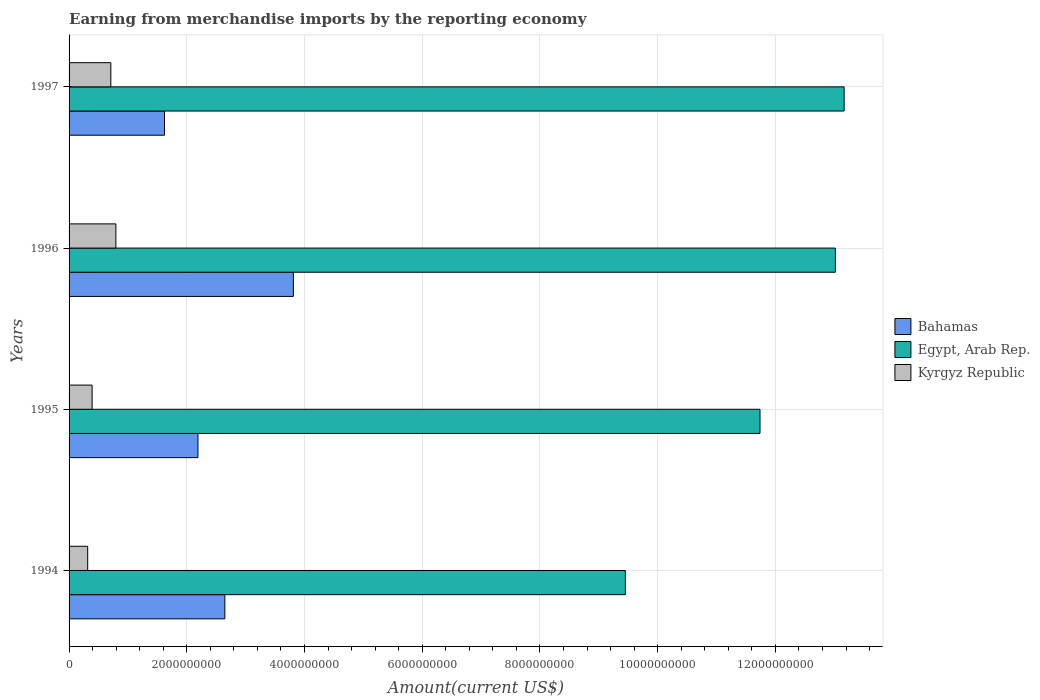Are the number of bars on each tick of the Y-axis equal?
Your answer should be very brief. Yes. How many bars are there on the 4th tick from the bottom?
Your response must be concise. 3. In how many cases, is the number of bars for a given year not equal to the number of legend labels?
Offer a terse response. 0. What is the amount earned from merchandise imports in Egypt, Arab Rep. in 1996?
Keep it short and to the point. 1.30e+1. Across all years, what is the maximum amount earned from merchandise imports in Kyrgyz Republic?
Ensure brevity in your answer.  7.95e+08. Across all years, what is the minimum amount earned from merchandise imports in Kyrgyz Republic?
Ensure brevity in your answer.  3.16e+08. What is the total amount earned from merchandise imports in Bahamas in the graph?
Provide a short and direct response. 1.03e+1. What is the difference between the amount earned from merchandise imports in Egypt, Arab Rep. in 1996 and that in 1997?
Your answer should be compact. -1.49e+08. What is the difference between the amount earned from merchandise imports in Kyrgyz Republic in 1994 and the amount earned from merchandise imports in Bahamas in 1996?
Keep it short and to the point. -3.49e+09. What is the average amount earned from merchandise imports in Bahamas per year?
Your answer should be very brief. 2.57e+09. In the year 1996, what is the difference between the amount earned from merchandise imports in Egypt, Arab Rep. and amount earned from merchandise imports in Kyrgyz Republic?
Ensure brevity in your answer.  1.22e+1. In how many years, is the amount earned from merchandise imports in Egypt, Arab Rep. greater than 400000000 US$?
Offer a terse response. 4. What is the ratio of the amount earned from merchandise imports in Kyrgyz Republic in 1994 to that in 1995?
Provide a short and direct response. 0.81. Is the difference between the amount earned from merchandise imports in Egypt, Arab Rep. in 1996 and 1997 greater than the difference between the amount earned from merchandise imports in Kyrgyz Republic in 1996 and 1997?
Give a very brief answer. No. What is the difference between the highest and the second highest amount earned from merchandise imports in Egypt, Arab Rep.?
Provide a short and direct response. 1.49e+08. What is the difference between the highest and the lowest amount earned from merchandise imports in Egypt, Arab Rep.?
Give a very brief answer. 3.72e+09. In how many years, is the amount earned from merchandise imports in Kyrgyz Republic greater than the average amount earned from merchandise imports in Kyrgyz Republic taken over all years?
Make the answer very short. 2. Is the sum of the amount earned from merchandise imports in Egypt, Arab Rep. in 1995 and 1996 greater than the maximum amount earned from merchandise imports in Kyrgyz Republic across all years?
Make the answer very short. Yes. What does the 3rd bar from the top in 1995 represents?
Provide a succinct answer. Bahamas. What does the 1st bar from the bottom in 1994 represents?
Offer a very short reply. Bahamas. Is it the case that in every year, the sum of the amount earned from merchandise imports in Egypt, Arab Rep. and amount earned from merchandise imports in Bahamas is greater than the amount earned from merchandise imports in Kyrgyz Republic?
Keep it short and to the point. Yes. How many bars are there?
Make the answer very short. 12. What is the difference between two consecutive major ticks on the X-axis?
Provide a short and direct response. 2.00e+09. Are the values on the major ticks of X-axis written in scientific E-notation?
Provide a short and direct response. No. Does the graph contain any zero values?
Offer a very short reply. No. Where does the legend appear in the graph?
Offer a very short reply. Center right. How are the legend labels stacked?
Make the answer very short. Vertical. What is the title of the graph?
Your response must be concise. Earning from merchandise imports by the reporting economy. What is the label or title of the X-axis?
Your response must be concise. Amount(current US$). What is the label or title of the Y-axis?
Make the answer very short. Years. What is the Amount(current US$) of Bahamas in 1994?
Make the answer very short. 2.65e+09. What is the Amount(current US$) in Egypt, Arab Rep. in 1994?
Offer a terse response. 9.45e+09. What is the Amount(current US$) of Kyrgyz Republic in 1994?
Make the answer very short. 3.16e+08. What is the Amount(current US$) of Bahamas in 1995?
Your answer should be very brief. 2.19e+09. What is the Amount(current US$) in Egypt, Arab Rep. in 1995?
Keep it short and to the point. 1.17e+1. What is the Amount(current US$) of Kyrgyz Republic in 1995?
Ensure brevity in your answer.  3.92e+08. What is the Amount(current US$) in Bahamas in 1996?
Provide a short and direct response. 3.81e+09. What is the Amount(current US$) of Egypt, Arab Rep. in 1996?
Your response must be concise. 1.30e+1. What is the Amount(current US$) of Kyrgyz Republic in 1996?
Give a very brief answer. 7.95e+08. What is the Amount(current US$) in Bahamas in 1997?
Offer a terse response. 1.62e+09. What is the Amount(current US$) of Egypt, Arab Rep. in 1997?
Ensure brevity in your answer.  1.32e+1. What is the Amount(current US$) in Kyrgyz Republic in 1997?
Give a very brief answer. 7.09e+08. Across all years, what is the maximum Amount(current US$) of Bahamas?
Your response must be concise. 3.81e+09. Across all years, what is the maximum Amount(current US$) in Egypt, Arab Rep.?
Give a very brief answer. 1.32e+1. Across all years, what is the maximum Amount(current US$) in Kyrgyz Republic?
Your answer should be very brief. 7.95e+08. Across all years, what is the minimum Amount(current US$) in Bahamas?
Offer a very short reply. 1.62e+09. Across all years, what is the minimum Amount(current US$) in Egypt, Arab Rep.?
Ensure brevity in your answer.  9.45e+09. Across all years, what is the minimum Amount(current US$) in Kyrgyz Republic?
Give a very brief answer. 3.16e+08. What is the total Amount(current US$) in Bahamas in the graph?
Provide a short and direct response. 1.03e+1. What is the total Amount(current US$) in Egypt, Arab Rep. in the graph?
Ensure brevity in your answer.  4.74e+1. What is the total Amount(current US$) in Kyrgyz Republic in the graph?
Provide a succinct answer. 2.21e+09. What is the difference between the Amount(current US$) in Bahamas in 1994 and that in 1995?
Provide a short and direct response. 4.57e+08. What is the difference between the Amount(current US$) of Egypt, Arab Rep. in 1994 and that in 1995?
Provide a short and direct response. -2.29e+09. What is the difference between the Amount(current US$) of Kyrgyz Republic in 1994 and that in 1995?
Provide a short and direct response. -7.51e+07. What is the difference between the Amount(current US$) of Bahamas in 1994 and that in 1996?
Your answer should be very brief. -1.16e+09. What is the difference between the Amount(current US$) of Egypt, Arab Rep. in 1994 and that in 1996?
Provide a short and direct response. -3.57e+09. What is the difference between the Amount(current US$) in Kyrgyz Republic in 1994 and that in 1996?
Give a very brief answer. -4.79e+08. What is the difference between the Amount(current US$) in Bahamas in 1994 and that in 1997?
Keep it short and to the point. 1.03e+09. What is the difference between the Amount(current US$) in Egypt, Arab Rep. in 1994 and that in 1997?
Provide a short and direct response. -3.72e+09. What is the difference between the Amount(current US$) of Kyrgyz Republic in 1994 and that in 1997?
Keep it short and to the point. -3.93e+08. What is the difference between the Amount(current US$) in Bahamas in 1995 and that in 1996?
Make the answer very short. -1.62e+09. What is the difference between the Amount(current US$) in Egypt, Arab Rep. in 1995 and that in 1996?
Give a very brief answer. -1.28e+09. What is the difference between the Amount(current US$) in Kyrgyz Republic in 1995 and that in 1996?
Provide a short and direct response. -4.04e+08. What is the difference between the Amount(current US$) of Bahamas in 1995 and that in 1997?
Your answer should be very brief. 5.68e+08. What is the difference between the Amount(current US$) in Egypt, Arab Rep. in 1995 and that in 1997?
Your answer should be compact. -1.43e+09. What is the difference between the Amount(current US$) of Kyrgyz Republic in 1995 and that in 1997?
Keep it short and to the point. -3.18e+08. What is the difference between the Amount(current US$) of Bahamas in 1996 and that in 1997?
Keep it short and to the point. 2.19e+09. What is the difference between the Amount(current US$) of Egypt, Arab Rep. in 1996 and that in 1997?
Make the answer very short. -1.49e+08. What is the difference between the Amount(current US$) of Kyrgyz Republic in 1996 and that in 1997?
Make the answer very short. 8.58e+07. What is the difference between the Amount(current US$) in Bahamas in 1994 and the Amount(current US$) in Egypt, Arab Rep. in 1995?
Your response must be concise. -9.09e+09. What is the difference between the Amount(current US$) in Bahamas in 1994 and the Amount(current US$) in Kyrgyz Republic in 1995?
Offer a very short reply. 2.26e+09. What is the difference between the Amount(current US$) in Egypt, Arab Rep. in 1994 and the Amount(current US$) in Kyrgyz Republic in 1995?
Ensure brevity in your answer.  9.06e+09. What is the difference between the Amount(current US$) of Bahamas in 1994 and the Amount(current US$) of Egypt, Arab Rep. in 1996?
Offer a very short reply. -1.04e+1. What is the difference between the Amount(current US$) of Bahamas in 1994 and the Amount(current US$) of Kyrgyz Republic in 1996?
Your answer should be compact. 1.85e+09. What is the difference between the Amount(current US$) in Egypt, Arab Rep. in 1994 and the Amount(current US$) in Kyrgyz Republic in 1996?
Your answer should be very brief. 8.66e+09. What is the difference between the Amount(current US$) of Bahamas in 1994 and the Amount(current US$) of Egypt, Arab Rep. in 1997?
Provide a succinct answer. -1.05e+1. What is the difference between the Amount(current US$) of Bahamas in 1994 and the Amount(current US$) of Kyrgyz Republic in 1997?
Offer a very short reply. 1.94e+09. What is the difference between the Amount(current US$) of Egypt, Arab Rep. in 1994 and the Amount(current US$) of Kyrgyz Republic in 1997?
Your answer should be compact. 8.74e+09. What is the difference between the Amount(current US$) in Bahamas in 1995 and the Amount(current US$) in Egypt, Arab Rep. in 1996?
Keep it short and to the point. -1.08e+1. What is the difference between the Amount(current US$) in Bahamas in 1995 and the Amount(current US$) in Kyrgyz Republic in 1996?
Ensure brevity in your answer.  1.39e+09. What is the difference between the Amount(current US$) of Egypt, Arab Rep. in 1995 and the Amount(current US$) of Kyrgyz Republic in 1996?
Offer a very short reply. 1.09e+1. What is the difference between the Amount(current US$) in Bahamas in 1995 and the Amount(current US$) in Egypt, Arab Rep. in 1997?
Offer a terse response. -1.10e+1. What is the difference between the Amount(current US$) of Bahamas in 1995 and the Amount(current US$) of Kyrgyz Republic in 1997?
Keep it short and to the point. 1.48e+09. What is the difference between the Amount(current US$) in Egypt, Arab Rep. in 1995 and the Amount(current US$) in Kyrgyz Republic in 1997?
Offer a very short reply. 1.10e+1. What is the difference between the Amount(current US$) in Bahamas in 1996 and the Amount(current US$) in Egypt, Arab Rep. in 1997?
Make the answer very short. -9.36e+09. What is the difference between the Amount(current US$) in Bahamas in 1996 and the Amount(current US$) in Kyrgyz Republic in 1997?
Your response must be concise. 3.10e+09. What is the difference between the Amount(current US$) of Egypt, Arab Rep. in 1996 and the Amount(current US$) of Kyrgyz Republic in 1997?
Offer a terse response. 1.23e+1. What is the average Amount(current US$) of Bahamas per year?
Offer a terse response. 2.57e+09. What is the average Amount(current US$) of Egypt, Arab Rep. per year?
Offer a very short reply. 1.18e+1. What is the average Amount(current US$) in Kyrgyz Republic per year?
Your answer should be compact. 5.53e+08. In the year 1994, what is the difference between the Amount(current US$) in Bahamas and Amount(current US$) in Egypt, Arab Rep.?
Give a very brief answer. -6.80e+09. In the year 1994, what is the difference between the Amount(current US$) of Bahamas and Amount(current US$) of Kyrgyz Republic?
Provide a succinct answer. 2.33e+09. In the year 1994, what is the difference between the Amount(current US$) of Egypt, Arab Rep. and Amount(current US$) of Kyrgyz Republic?
Offer a very short reply. 9.14e+09. In the year 1995, what is the difference between the Amount(current US$) in Bahamas and Amount(current US$) in Egypt, Arab Rep.?
Ensure brevity in your answer.  -9.55e+09. In the year 1995, what is the difference between the Amount(current US$) of Bahamas and Amount(current US$) of Kyrgyz Republic?
Make the answer very short. 1.80e+09. In the year 1995, what is the difference between the Amount(current US$) in Egypt, Arab Rep. and Amount(current US$) in Kyrgyz Republic?
Offer a terse response. 1.13e+1. In the year 1996, what is the difference between the Amount(current US$) of Bahamas and Amount(current US$) of Egypt, Arab Rep.?
Offer a very short reply. -9.21e+09. In the year 1996, what is the difference between the Amount(current US$) in Bahamas and Amount(current US$) in Kyrgyz Republic?
Your answer should be very brief. 3.02e+09. In the year 1996, what is the difference between the Amount(current US$) of Egypt, Arab Rep. and Amount(current US$) of Kyrgyz Republic?
Keep it short and to the point. 1.22e+1. In the year 1997, what is the difference between the Amount(current US$) in Bahamas and Amount(current US$) in Egypt, Arab Rep.?
Provide a short and direct response. -1.15e+1. In the year 1997, what is the difference between the Amount(current US$) of Bahamas and Amount(current US$) of Kyrgyz Republic?
Make the answer very short. 9.12e+08. In the year 1997, what is the difference between the Amount(current US$) in Egypt, Arab Rep. and Amount(current US$) in Kyrgyz Republic?
Ensure brevity in your answer.  1.25e+1. What is the ratio of the Amount(current US$) of Bahamas in 1994 to that in 1995?
Provide a succinct answer. 1.21. What is the ratio of the Amount(current US$) in Egypt, Arab Rep. in 1994 to that in 1995?
Offer a terse response. 0.81. What is the ratio of the Amount(current US$) in Kyrgyz Republic in 1994 to that in 1995?
Your answer should be compact. 0.81. What is the ratio of the Amount(current US$) in Bahamas in 1994 to that in 1996?
Provide a short and direct response. 0.69. What is the ratio of the Amount(current US$) in Egypt, Arab Rep. in 1994 to that in 1996?
Provide a short and direct response. 0.73. What is the ratio of the Amount(current US$) of Kyrgyz Republic in 1994 to that in 1996?
Offer a terse response. 0.4. What is the ratio of the Amount(current US$) in Bahamas in 1994 to that in 1997?
Keep it short and to the point. 1.63. What is the ratio of the Amount(current US$) of Egypt, Arab Rep. in 1994 to that in 1997?
Provide a succinct answer. 0.72. What is the ratio of the Amount(current US$) in Kyrgyz Republic in 1994 to that in 1997?
Make the answer very short. 0.45. What is the ratio of the Amount(current US$) of Bahamas in 1995 to that in 1996?
Make the answer very short. 0.57. What is the ratio of the Amount(current US$) of Egypt, Arab Rep. in 1995 to that in 1996?
Your answer should be compact. 0.9. What is the ratio of the Amount(current US$) of Kyrgyz Republic in 1995 to that in 1996?
Your answer should be compact. 0.49. What is the ratio of the Amount(current US$) of Bahamas in 1995 to that in 1997?
Ensure brevity in your answer.  1.35. What is the ratio of the Amount(current US$) of Egypt, Arab Rep. in 1995 to that in 1997?
Make the answer very short. 0.89. What is the ratio of the Amount(current US$) of Kyrgyz Republic in 1995 to that in 1997?
Provide a short and direct response. 0.55. What is the ratio of the Amount(current US$) of Bahamas in 1996 to that in 1997?
Your answer should be compact. 2.35. What is the ratio of the Amount(current US$) of Egypt, Arab Rep. in 1996 to that in 1997?
Your answer should be compact. 0.99. What is the ratio of the Amount(current US$) of Kyrgyz Republic in 1996 to that in 1997?
Your answer should be very brief. 1.12. What is the difference between the highest and the second highest Amount(current US$) of Bahamas?
Your answer should be compact. 1.16e+09. What is the difference between the highest and the second highest Amount(current US$) in Egypt, Arab Rep.?
Provide a succinct answer. 1.49e+08. What is the difference between the highest and the second highest Amount(current US$) in Kyrgyz Republic?
Your response must be concise. 8.58e+07. What is the difference between the highest and the lowest Amount(current US$) of Bahamas?
Your response must be concise. 2.19e+09. What is the difference between the highest and the lowest Amount(current US$) in Egypt, Arab Rep.?
Keep it short and to the point. 3.72e+09. What is the difference between the highest and the lowest Amount(current US$) in Kyrgyz Republic?
Keep it short and to the point. 4.79e+08. 